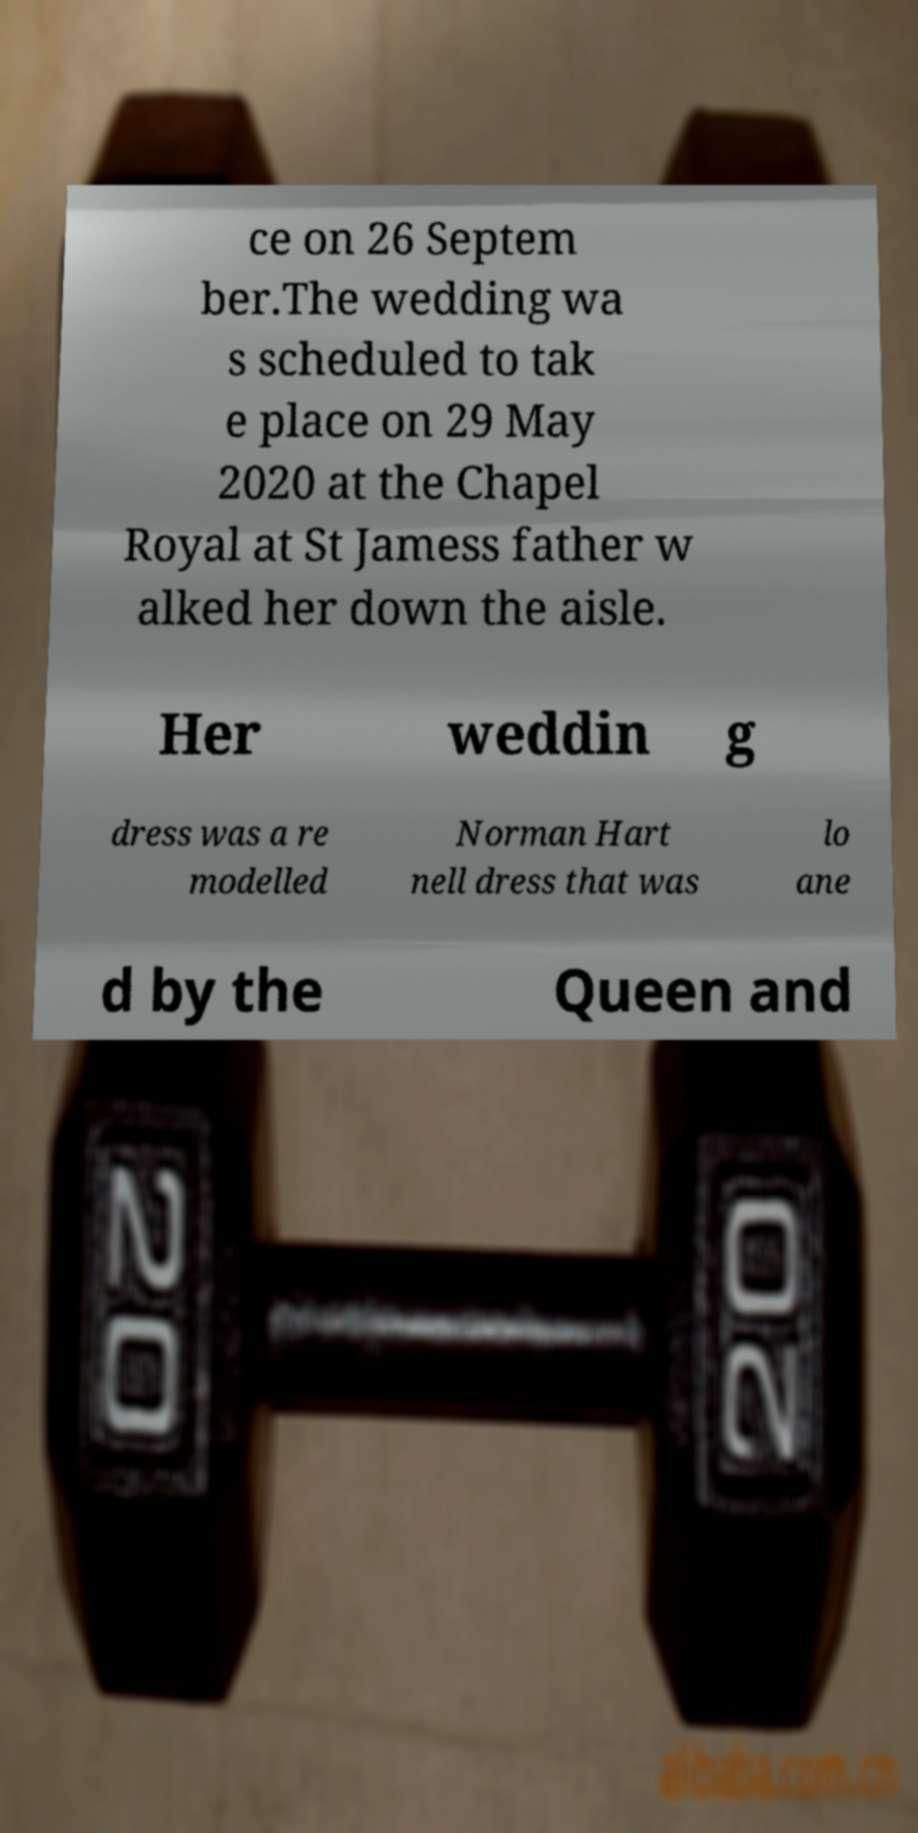Could you assist in decoding the text presented in this image and type it out clearly? ce on 26 Septem ber.The wedding wa s scheduled to tak e place on 29 May 2020 at the Chapel Royal at St Jamess father w alked her down the aisle. Her weddin g dress was a re modelled Norman Hart nell dress that was lo ane d by the Queen and 